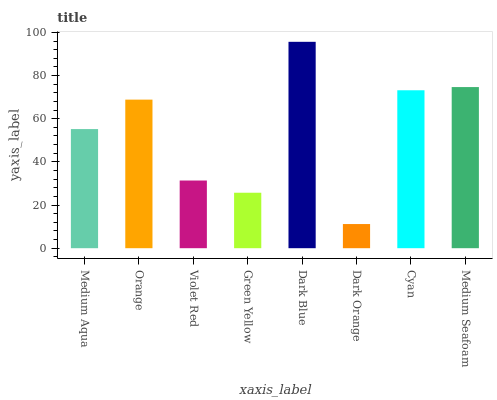Is Dark Orange the minimum?
Answer yes or no. Yes. Is Dark Blue the maximum?
Answer yes or no. Yes. Is Orange the minimum?
Answer yes or no. No. Is Orange the maximum?
Answer yes or no. No. Is Orange greater than Medium Aqua?
Answer yes or no. Yes. Is Medium Aqua less than Orange?
Answer yes or no. Yes. Is Medium Aqua greater than Orange?
Answer yes or no. No. Is Orange less than Medium Aqua?
Answer yes or no. No. Is Orange the high median?
Answer yes or no. Yes. Is Medium Aqua the low median?
Answer yes or no. Yes. Is Dark Orange the high median?
Answer yes or no. No. Is Dark Orange the low median?
Answer yes or no. No. 